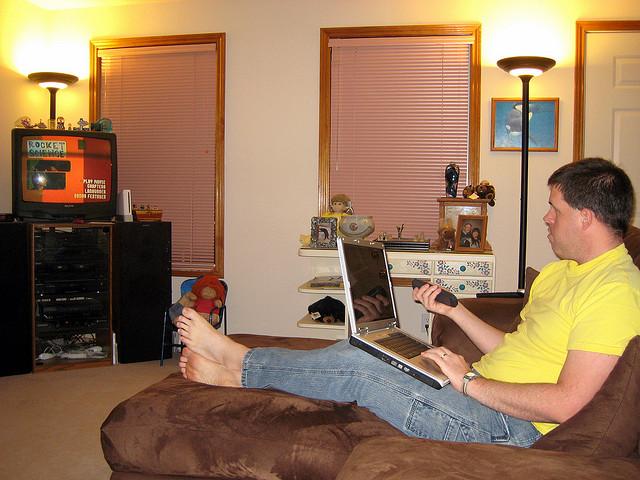What color is the man's shirt?
Concise answer only. Yellow. What room in the house is this man in?
Keep it brief. Living room. What is the television sitting on?
Give a very brief answer. Stereo. Is the photo blurry?
Quick response, please. No. 